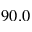Convert formula to latex. <formula><loc_0><loc_0><loc_500><loc_500>9 0 . 0</formula> 